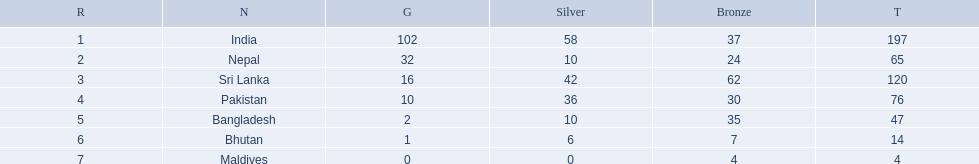Which countries won medals? India, Nepal, Sri Lanka, Pakistan, Bangladesh, Bhutan, Maldives. Which won the most? India. Which won the fewest? Maldives. 